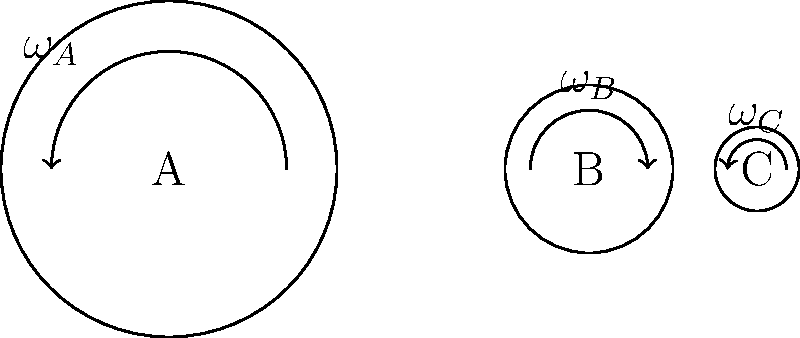In the gear arrangement shown, gear A has a radius of 10 cm and rotates at 100 rpm. Gear B has a radius of 5 cm, and gear C has a radius of 2.5 cm. If the efficiency of power transmission between gears A and B is 95%, and between B and C is 90%, what is the overall efficiency of the system, and what is the angular velocity of gear C in rad/s? To solve this problem, let's follow these steps:

1. Calculate the angular velocity of gear A:
   $\omega_A = 100 \text{ rpm} \times \frac{2\pi \text{ rad}}{60 \text{ s}} = \frac{10\pi}{3} \text{ rad/s}$

2. Use the gear ratio to find the angular velocity of gear B:
   $\frac{\omega_A}{\omega_B} = \frac{r_B}{r_A}$
   $\omega_B = \omega_A \times \frac{r_A}{r_B} = \frac{10\pi}{3} \times \frac{10}{5} = \frac{20\pi}{3} \text{ rad/s}$

3. Similarly, find the angular velocity of gear C:
   $\frac{\omega_B}{\omega_C} = \frac{r_C}{r_B}$
   $\omega_C = \omega_B \times \frac{r_B}{r_C} = \frac{20\pi}{3} \times \frac{5}{2.5} = \frac{40\pi}{3} \text{ rad/s}$

4. Calculate the overall efficiency:
   Efficiency = (Efficiency between A and B) × (Efficiency between B and C)
   $\eta_{\text{overall}} = 0.95 \times 0.90 = 0.855 \text{ or } 85.5\%$
Answer: Overall efficiency: 85.5%, Angular velocity of gear C: $\frac{40\pi}{3} \text{ rad/s}$ 